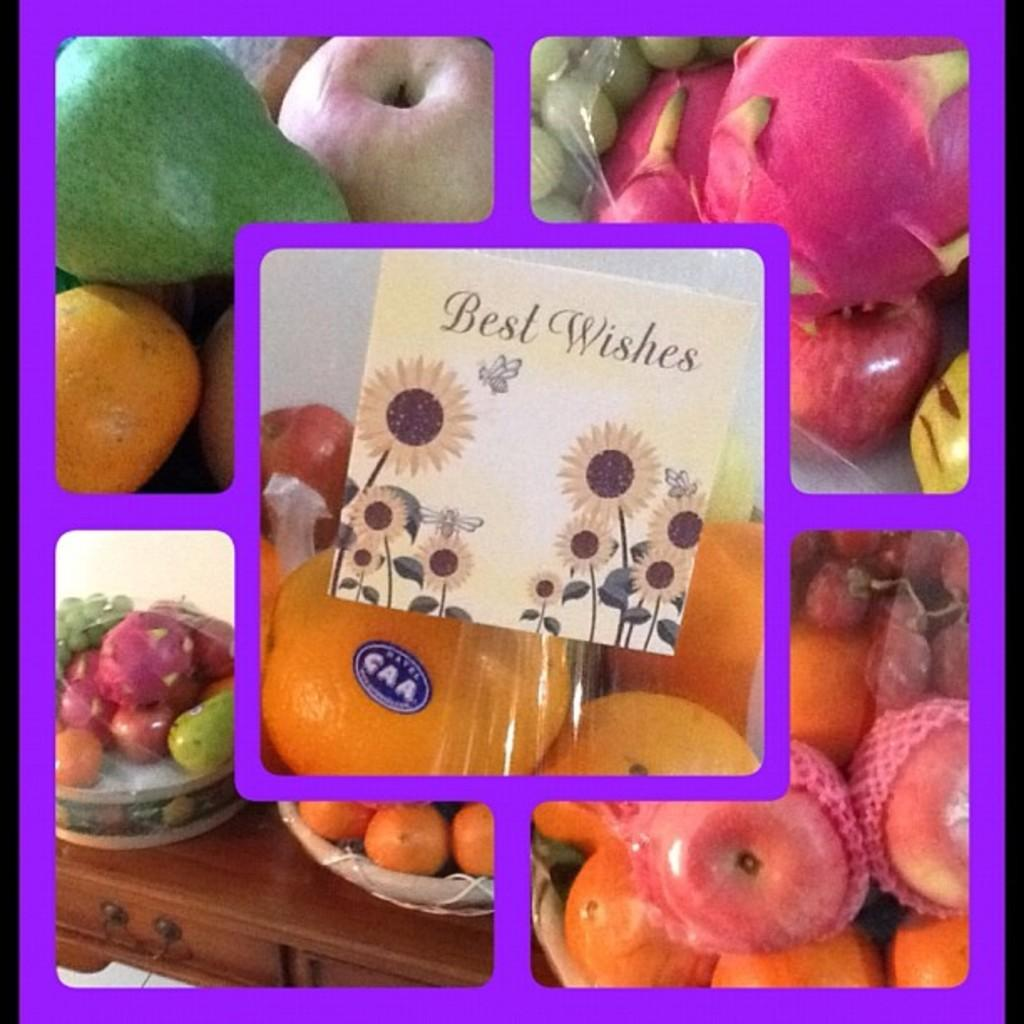What type of artwork is depicted in the image? The image is a collage. What can be found in the collage? There are different kinds of fruits in the image. Can you describe the wooden object in the image? There are baskets on a wooden object in one part of the image. What type of pear is being used as a pot in the image? There is no pear or pot present in the image. How many marbles are visible in the image? There are no marbles visible in the image. 